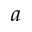Convert formula to latex. <formula><loc_0><loc_0><loc_500><loc_500>a</formula> 